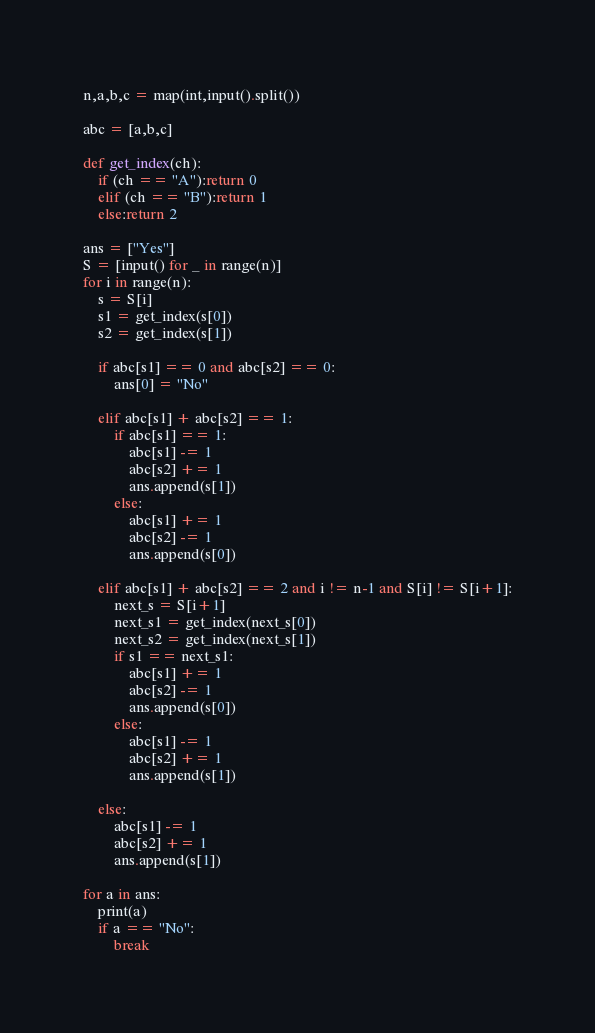Convert code to text. <code><loc_0><loc_0><loc_500><loc_500><_Python_>n,a,b,c = map(int,input().split())

abc = [a,b,c]

def get_index(ch):
    if (ch == "A"):return 0
    elif (ch == "B"):return 1
    else:return 2

ans = ["Yes"]
S = [input() for _ in range(n)]
for i in range(n):
    s = S[i]
    s1 = get_index(s[0])
    s2 = get_index(s[1])
    
    if abc[s1] == 0 and abc[s2] == 0:
        ans[0] = "No"
    
    elif abc[s1] + abc[s2] == 1:
        if abc[s1] == 1:
            abc[s1] -= 1
            abc[s2] += 1
            ans.append(s[1])
        else:
            abc[s1] += 1
            abc[s2] -= 1
            ans.append(s[0])
    
    elif abc[s1] + abc[s2] == 2 and i != n-1 and S[i] != S[i+1]:
        next_s = S[i+1]
        next_s1 = get_index(next_s[0])
        next_s2 = get_index(next_s[1]) 
        if s1 == next_s1:
            abc[s1] += 1
            abc[s2] -= 1
            ans.append(s[0])
        else:
            abc[s1] -= 1
            abc[s2] += 1
            ans.append(s[1])
    
    else:
        abc[s1] -= 1
        abc[s2] += 1
        ans.append(s[1])

for a in ans:
    print(a)
    if a == "No":
        break</code> 